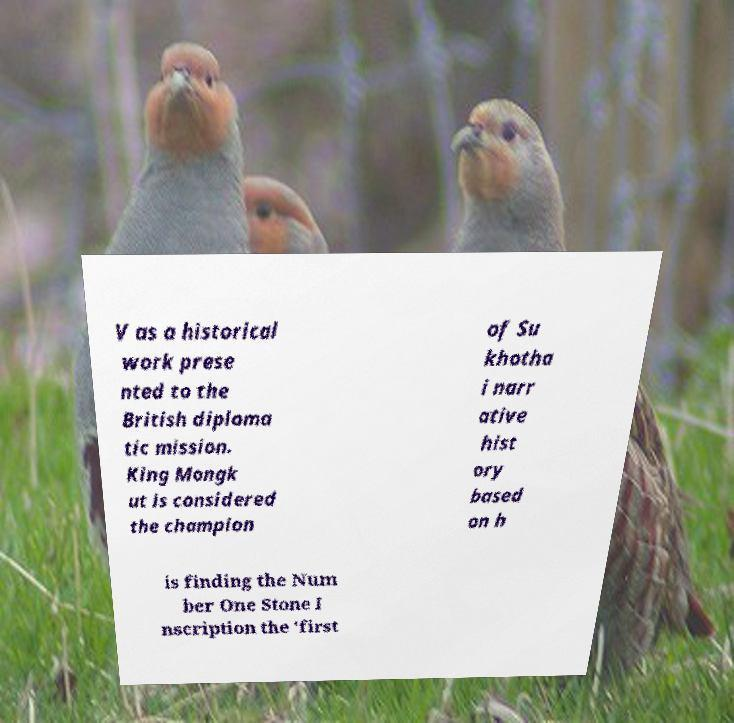There's text embedded in this image that I need extracted. Can you transcribe it verbatim? V as a historical work prese nted to the British diploma tic mission. King Mongk ut is considered the champion of Su khotha i narr ative hist ory based on h is finding the Num ber One Stone I nscription the 'first 